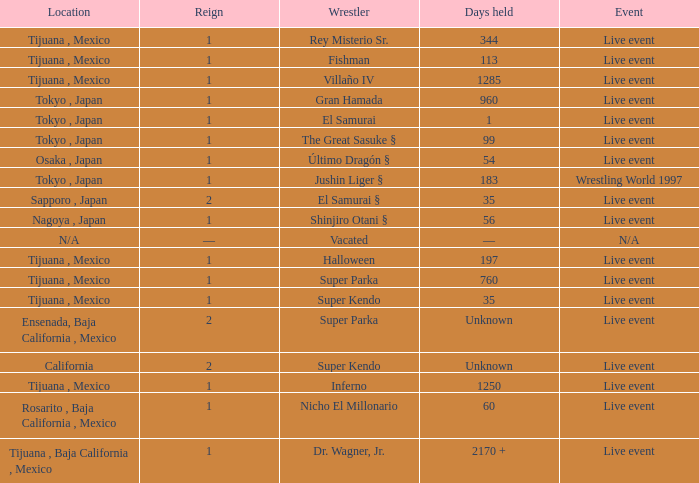What type of event had the wrestler with a reign of 2 and held the title for 35 days? Live event. 